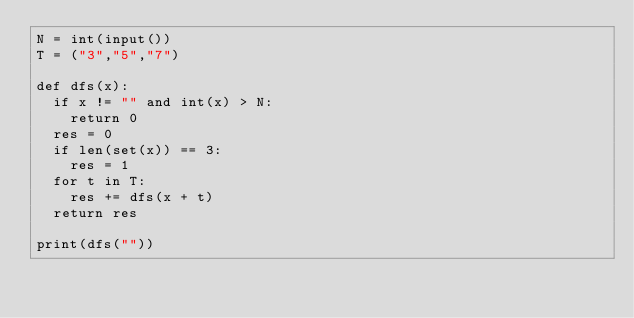<code> <loc_0><loc_0><loc_500><loc_500><_Python_>N = int(input())
T = ("3","5","7")

def dfs(x):
  if x != "" and int(x) > N:
    return 0
  res = 0
  if len(set(x)) == 3:
    res = 1
  for t in T:
    res += dfs(x + t)
  return res
  
print(dfs(""))</code> 